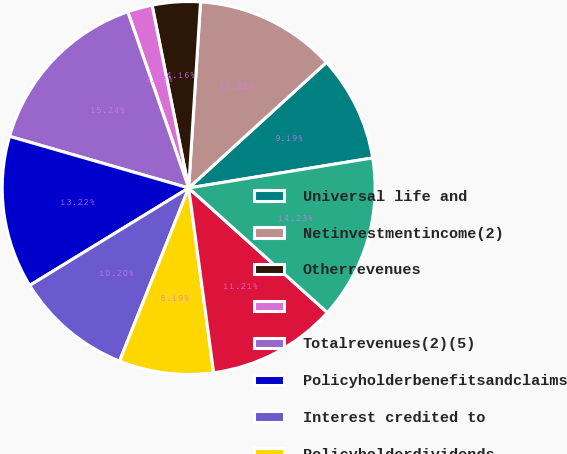<chart> <loc_0><loc_0><loc_500><loc_500><pie_chart><fcel>Universal life and<fcel>Netinvestmentincome(2)<fcel>Otherrevenues<fcel>Unnamed: 3<fcel>Totalrevenues(2)(5)<fcel>Policyholderbenefitsandclaims<fcel>Interest credited to<fcel>Policyholderdividends<fcel>Otherexpenses<fcel>Totalexpenses(2)(5)<nl><fcel>9.19%<fcel>12.22%<fcel>4.16%<fcel>2.15%<fcel>15.24%<fcel>13.22%<fcel>10.2%<fcel>8.19%<fcel>11.21%<fcel>14.23%<nl></chart> 